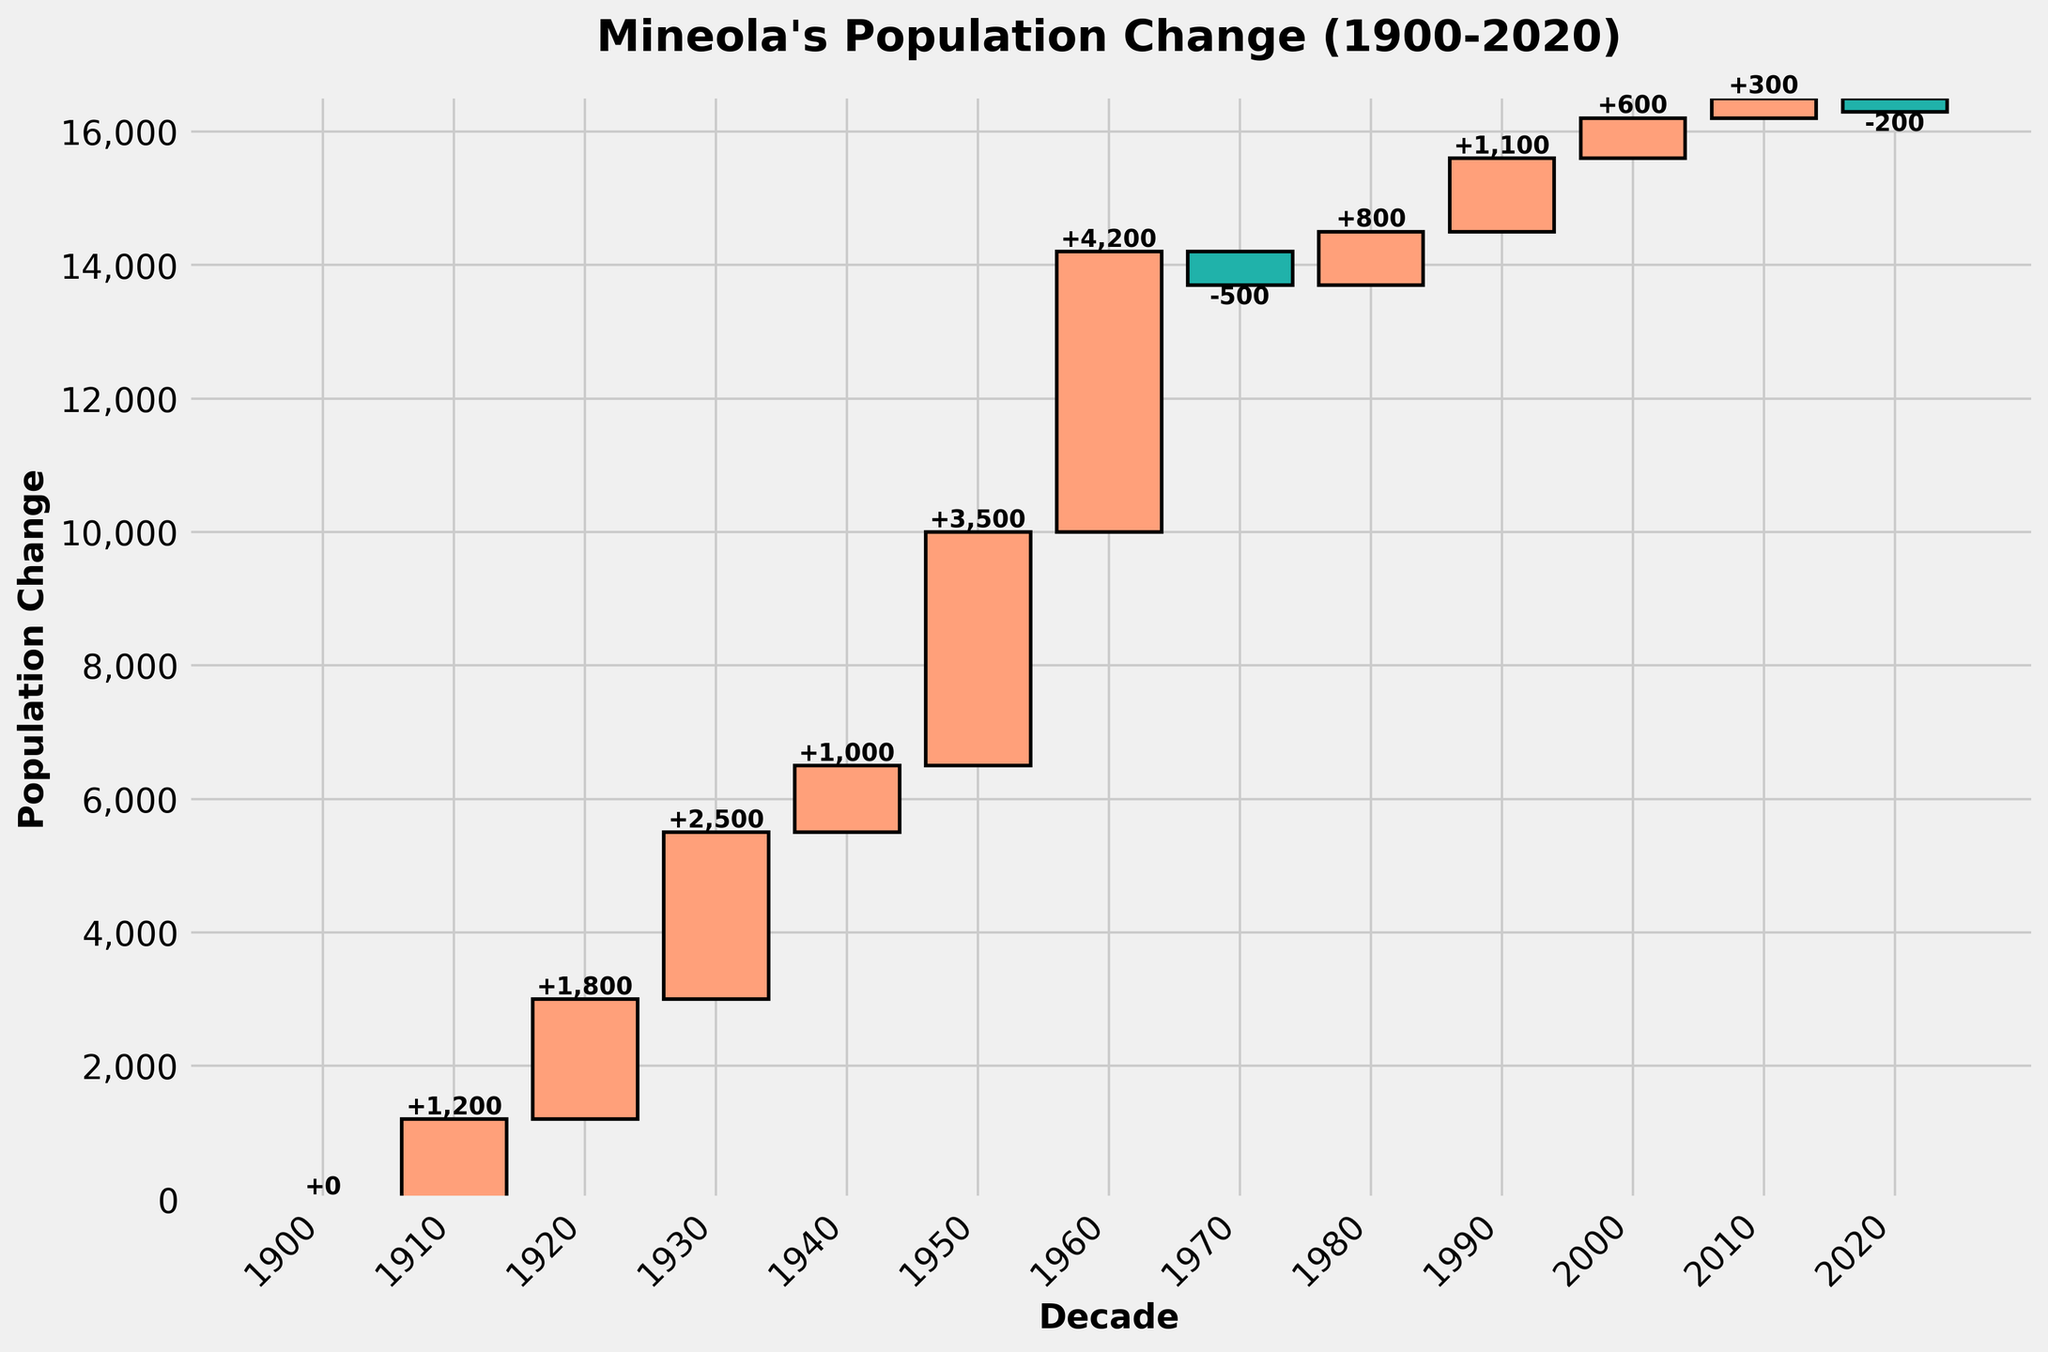When did Mineola see the highest increase in population within a decade? The highest increase is indicated by the tallest bar in the waterfall chart. This bar shows a population change of 4,200 between 1950 and 1960.
Answer: Between 1950 and 1960 What is the total population change from 1900 to 2020? To find the total population change over the entire period, sum all decade population changes: 0 + 1200 + 1800 + 2500 + 1000 + 3500 + 4200 - 500 + 800 + 1100 + 600 + 300 - 200 = 13,300.
Answer: 13,300 How many decades had a population decrease? Count the bars that point downward, representing decades with a negative population change. The chart has two such bars, corresponding to the 1970s and 2010s.
Answer: 2 decades What was the population change in the 1970s? Find the bar corresponding to the 1970s; it shows a decrease represented by -500.
Answer: -500 Which decade contributed the least to the population change? The bar with the smallest absolute value represents the smallest population change. This is the 2010s with a change of -200.
Answer: 2010s During which decades did Mineola experience positive population growth? Positive population growth is indicated by bars pointing upwards. The decades with positive growth are 1910s, 1920s, 1930s, 1940s, 1950s, 1960s, 1980s, 1990s, and 2000s.
Answer: 1910s, 1920s, 1930s, 1940s, 1950s, 1960s, 1980s, 1990s, 2000s Comparing the 1920s and 2000s, during which decade did Mineola have a higher population increase? Compare the bars for the 1920s (1,800) and 2000s (600). The 1920s bar is higher.
Answer: 1920s What was the population change between the 1980s and 1990s combined? Add the population changes of the 1980s and 1990s: 800 + 1,100 = 1,900.
Answer: 1,900 Did Mineola's population grow or shrink between 1940 and 1950? The bar for the 1940s shows an increase of 1,000, indicating growth.
Answer: Grow What pattern is observed in Mineola’s population changes during the 1960s and 1970s? In the 1960s, there is a significant increase (4,200), followed by a decrease in the 1970s (-500).
Answer: Increase followed by decrease 